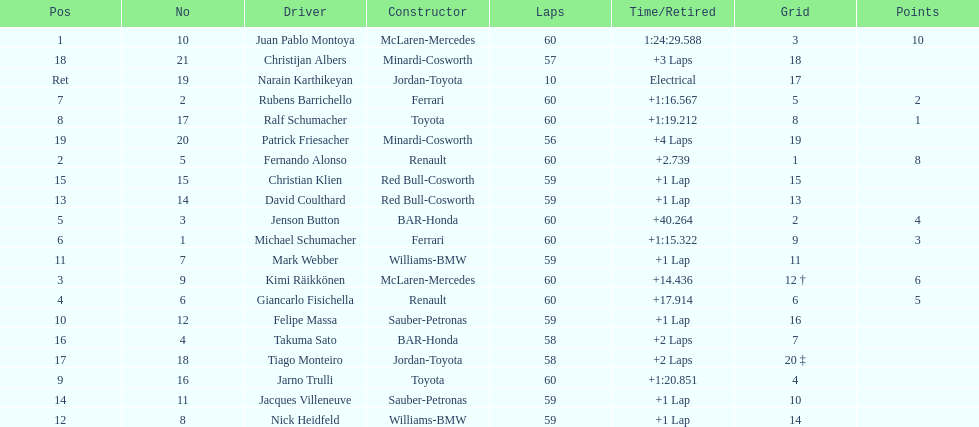Which driver has the least amount of points? Ralf Schumacher. 